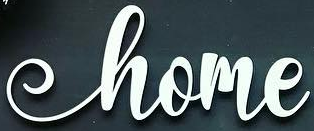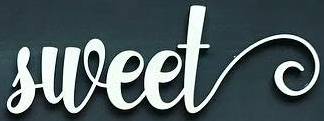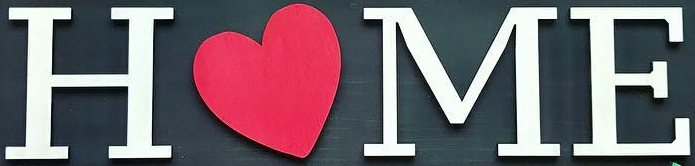What text appears in these images from left to right, separated by a semicolon? home; sweet; HOME 